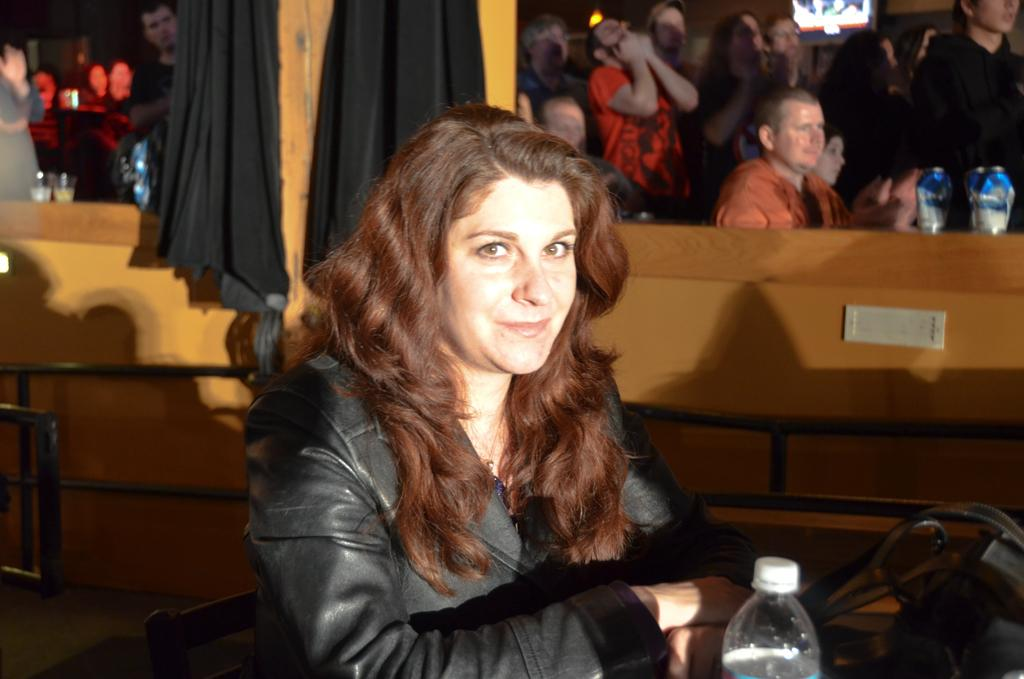Who is present in the image? There is a woman in the image. What is the woman wearing? The woman is wearing a black jacket. What is the woman's facial expression? The woman is smiling. What items can be seen near the woman? There is a water bottle and a bag in the image. Can you describe the group of people behind the woman? There is a group of people behind the woman, but their specific features are not mentioned in the facts. What type of volleyball game is being played by the geese in the image? There is no volleyball game or geese present in the image. How many cakes are being served to the group of people in the image? The facts do not mention any cakes being served to the group of people in the image. 